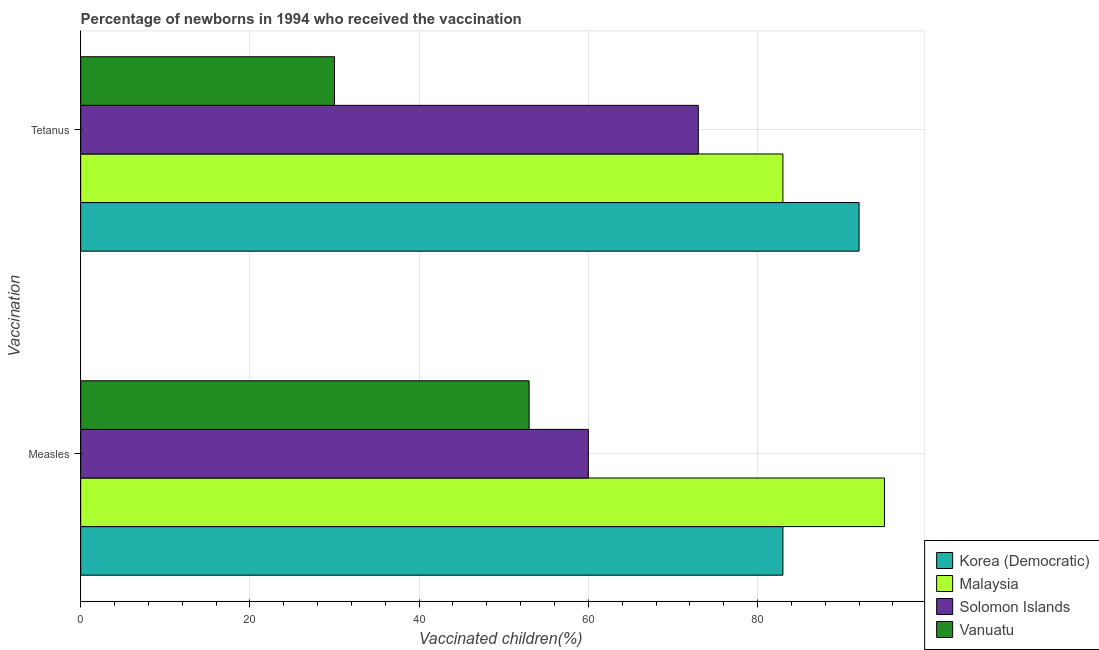How many different coloured bars are there?
Ensure brevity in your answer.  4. Are the number of bars on each tick of the Y-axis equal?
Ensure brevity in your answer.  Yes. What is the label of the 2nd group of bars from the top?
Your answer should be compact. Measles. What is the percentage of newborns who received vaccination for tetanus in Solomon Islands?
Ensure brevity in your answer.  73. Across all countries, what is the maximum percentage of newborns who received vaccination for tetanus?
Offer a terse response. 92. Across all countries, what is the minimum percentage of newborns who received vaccination for measles?
Your answer should be compact. 53. In which country was the percentage of newborns who received vaccination for measles maximum?
Ensure brevity in your answer.  Malaysia. In which country was the percentage of newborns who received vaccination for measles minimum?
Offer a very short reply. Vanuatu. What is the total percentage of newborns who received vaccination for tetanus in the graph?
Provide a short and direct response. 278. What is the difference between the percentage of newborns who received vaccination for measles in Solomon Islands and that in Malaysia?
Your answer should be compact. -35. What is the difference between the percentage of newborns who received vaccination for tetanus in Vanuatu and the percentage of newborns who received vaccination for measles in Korea (Democratic)?
Your answer should be very brief. -53. What is the average percentage of newborns who received vaccination for measles per country?
Ensure brevity in your answer.  72.75. What is the difference between the percentage of newborns who received vaccination for measles and percentage of newborns who received vaccination for tetanus in Solomon Islands?
Provide a succinct answer. -13. In how many countries, is the percentage of newborns who received vaccination for tetanus greater than 32 %?
Provide a short and direct response. 3. What is the ratio of the percentage of newborns who received vaccination for tetanus in Korea (Democratic) to that in Malaysia?
Your answer should be compact. 1.11. In how many countries, is the percentage of newborns who received vaccination for measles greater than the average percentage of newborns who received vaccination for measles taken over all countries?
Ensure brevity in your answer.  2. What does the 4th bar from the top in Tetanus represents?
Offer a very short reply. Korea (Democratic). What does the 1st bar from the bottom in Measles represents?
Your response must be concise. Korea (Democratic). How many bars are there?
Ensure brevity in your answer.  8. Does the graph contain any zero values?
Your answer should be compact. No. Does the graph contain grids?
Your answer should be compact. Yes. How are the legend labels stacked?
Give a very brief answer. Vertical. What is the title of the graph?
Make the answer very short. Percentage of newborns in 1994 who received the vaccination. Does "Middle income" appear as one of the legend labels in the graph?
Keep it short and to the point. No. What is the label or title of the X-axis?
Ensure brevity in your answer.  Vaccinated children(%)
. What is the label or title of the Y-axis?
Keep it short and to the point. Vaccination. What is the Vaccinated children(%)
 in Malaysia in Measles?
Keep it short and to the point. 95. What is the Vaccinated children(%)
 in Vanuatu in Measles?
Your answer should be very brief. 53. What is the Vaccinated children(%)
 in Korea (Democratic) in Tetanus?
Your answer should be very brief. 92. What is the Vaccinated children(%)
 of Malaysia in Tetanus?
Offer a terse response. 83. Across all Vaccination, what is the maximum Vaccinated children(%)
 of Korea (Democratic)?
Give a very brief answer. 92. Across all Vaccination, what is the maximum Vaccinated children(%)
 of Malaysia?
Offer a terse response. 95. Across all Vaccination, what is the maximum Vaccinated children(%)
 in Solomon Islands?
Keep it short and to the point. 73. Across all Vaccination, what is the maximum Vaccinated children(%)
 of Vanuatu?
Ensure brevity in your answer.  53. Across all Vaccination, what is the minimum Vaccinated children(%)
 in Korea (Democratic)?
Make the answer very short. 83. Across all Vaccination, what is the minimum Vaccinated children(%)
 of Malaysia?
Your answer should be very brief. 83. Across all Vaccination, what is the minimum Vaccinated children(%)
 in Solomon Islands?
Your answer should be very brief. 60. What is the total Vaccinated children(%)
 of Korea (Democratic) in the graph?
Make the answer very short. 175. What is the total Vaccinated children(%)
 in Malaysia in the graph?
Make the answer very short. 178. What is the total Vaccinated children(%)
 in Solomon Islands in the graph?
Provide a short and direct response. 133. What is the difference between the Vaccinated children(%)
 in Korea (Democratic) in Measles and that in Tetanus?
Your answer should be compact. -9. What is the difference between the Vaccinated children(%)
 of Solomon Islands in Measles and that in Tetanus?
Give a very brief answer. -13. What is the difference between the Vaccinated children(%)
 in Korea (Democratic) in Measles and the Vaccinated children(%)
 in Malaysia in Tetanus?
Make the answer very short. 0. What is the difference between the Vaccinated children(%)
 of Malaysia in Measles and the Vaccinated children(%)
 of Solomon Islands in Tetanus?
Your answer should be compact. 22. What is the difference between the Vaccinated children(%)
 in Malaysia in Measles and the Vaccinated children(%)
 in Vanuatu in Tetanus?
Offer a very short reply. 65. What is the difference between the Vaccinated children(%)
 in Solomon Islands in Measles and the Vaccinated children(%)
 in Vanuatu in Tetanus?
Your response must be concise. 30. What is the average Vaccinated children(%)
 of Korea (Democratic) per Vaccination?
Make the answer very short. 87.5. What is the average Vaccinated children(%)
 in Malaysia per Vaccination?
Provide a succinct answer. 89. What is the average Vaccinated children(%)
 of Solomon Islands per Vaccination?
Make the answer very short. 66.5. What is the average Vaccinated children(%)
 in Vanuatu per Vaccination?
Offer a very short reply. 41.5. What is the difference between the Vaccinated children(%)
 of Korea (Democratic) and Vaccinated children(%)
 of Malaysia in Measles?
Offer a very short reply. -12. What is the difference between the Vaccinated children(%)
 in Korea (Democratic) and Vaccinated children(%)
 in Solomon Islands in Measles?
Your response must be concise. 23. What is the difference between the Vaccinated children(%)
 in Korea (Democratic) and Vaccinated children(%)
 in Vanuatu in Measles?
Your response must be concise. 30. What is the difference between the Vaccinated children(%)
 in Malaysia and Vaccinated children(%)
 in Solomon Islands in Measles?
Offer a very short reply. 35. What is the difference between the Vaccinated children(%)
 in Malaysia and Vaccinated children(%)
 in Vanuatu in Measles?
Keep it short and to the point. 42. What is the difference between the Vaccinated children(%)
 in Korea (Democratic) and Vaccinated children(%)
 in Solomon Islands in Tetanus?
Provide a short and direct response. 19. What is the difference between the Vaccinated children(%)
 in Malaysia and Vaccinated children(%)
 in Solomon Islands in Tetanus?
Give a very brief answer. 10. What is the ratio of the Vaccinated children(%)
 in Korea (Democratic) in Measles to that in Tetanus?
Provide a succinct answer. 0.9. What is the ratio of the Vaccinated children(%)
 of Malaysia in Measles to that in Tetanus?
Provide a short and direct response. 1.14. What is the ratio of the Vaccinated children(%)
 of Solomon Islands in Measles to that in Tetanus?
Your answer should be very brief. 0.82. What is the ratio of the Vaccinated children(%)
 of Vanuatu in Measles to that in Tetanus?
Make the answer very short. 1.77. What is the difference between the highest and the second highest Vaccinated children(%)
 of Vanuatu?
Your answer should be compact. 23. What is the difference between the highest and the lowest Vaccinated children(%)
 of Korea (Democratic)?
Ensure brevity in your answer.  9. What is the difference between the highest and the lowest Vaccinated children(%)
 in Malaysia?
Make the answer very short. 12. What is the difference between the highest and the lowest Vaccinated children(%)
 in Solomon Islands?
Your response must be concise. 13. 